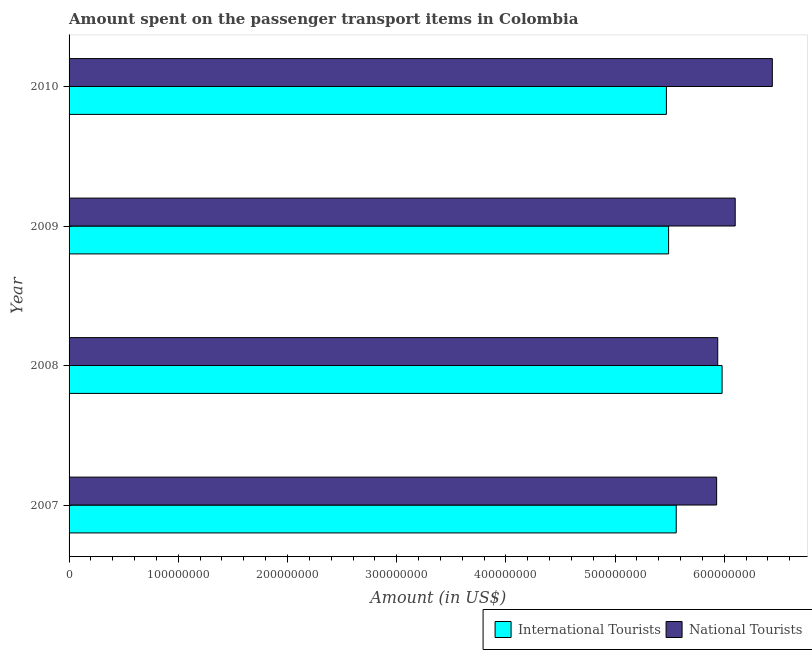Are the number of bars per tick equal to the number of legend labels?
Offer a terse response. Yes. How many bars are there on the 2nd tick from the top?
Your response must be concise. 2. How many bars are there on the 1st tick from the bottom?
Make the answer very short. 2. What is the label of the 1st group of bars from the top?
Keep it short and to the point. 2010. In how many cases, is the number of bars for a given year not equal to the number of legend labels?
Your answer should be very brief. 0. What is the amount spent on transport items of national tourists in 2008?
Offer a very short reply. 5.94e+08. Across all years, what is the maximum amount spent on transport items of national tourists?
Offer a terse response. 6.44e+08. Across all years, what is the minimum amount spent on transport items of national tourists?
Your answer should be compact. 5.93e+08. In which year was the amount spent on transport items of international tourists maximum?
Your answer should be very brief. 2008. In which year was the amount spent on transport items of national tourists minimum?
Your response must be concise. 2007. What is the total amount spent on transport items of national tourists in the graph?
Provide a succinct answer. 2.44e+09. What is the difference between the amount spent on transport items of national tourists in 2009 and that in 2010?
Your answer should be very brief. -3.40e+07. What is the difference between the amount spent on transport items of international tourists in 2008 and the amount spent on transport items of national tourists in 2007?
Provide a succinct answer. 5.00e+06. What is the average amount spent on transport items of national tourists per year?
Keep it short and to the point. 6.10e+08. In the year 2010, what is the difference between the amount spent on transport items of international tourists and amount spent on transport items of national tourists?
Your response must be concise. -9.70e+07. In how many years, is the amount spent on transport items of national tourists greater than 380000000 US$?
Your answer should be compact. 4. What is the ratio of the amount spent on transport items of national tourists in 2007 to that in 2010?
Offer a terse response. 0.92. Is the amount spent on transport items of international tourists in 2007 less than that in 2008?
Provide a succinct answer. Yes. Is the difference between the amount spent on transport items of national tourists in 2007 and 2008 greater than the difference between the amount spent on transport items of international tourists in 2007 and 2008?
Ensure brevity in your answer.  Yes. What is the difference between the highest and the second highest amount spent on transport items of international tourists?
Your answer should be compact. 4.20e+07. What is the difference between the highest and the lowest amount spent on transport items of national tourists?
Give a very brief answer. 5.10e+07. Is the sum of the amount spent on transport items of national tourists in 2008 and 2010 greater than the maximum amount spent on transport items of international tourists across all years?
Make the answer very short. Yes. What does the 1st bar from the top in 2007 represents?
Provide a succinct answer. National Tourists. What does the 1st bar from the bottom in 2009 represents?
Your answer should be compact. International Tourists. How many bars are there?
Ensure brevity in your answer.  8. What is the difference between two consecutive major ticks on the X-axis?
Keep it short and to the point. 1.00e+08. Are the values on the major ticks of X-axis written in scientific E-notation?
Provide a short and direct response. No. Where does the legend appear in the graph?
Keep it short and to the point. Bottom right. What is the title of the graph?
Make the answer very short. Amount spent on the passenger transport items in Colombia. Does "Male labourers" appear as one of the legend labels in the graph?
Ensure brevity in your answer.  No. What is the label or title of the Y-axis?
Offer a very short reply. Year. What is the Amount (in US$) of International Tourists in 2007?
Your answer should be very brief. 5.56e+08. What is the Amount (in US$) in National Tourists in 2007?
Give a very brief answer. 5.93e+08. What is the Amount (in US$) in International Tourists in 2008?
Your answer should be very brief. 5.98e+08. What is the Amount (in US$) of National Tourists in 2008?
Make the answer very short. 5.94e+08. What is the Amount (in US$) of International Tourists in 2009?
Make the answer very short. 5.49e+08. What is the Amount (in US$) in National Tourists in 2009?
Keep it short and to the point. 6.10e+08. What is the Amount (in US$) in International Tourists in 2010?
Offer a very short reply. 5.47e+08. What is the Amount (in US$) of National Tourists in 2010?
Offer a terse response. 6.44e+08. Across all years, what is the maximum Amount (in US$) of International Tourists?
Provide a short and direct response. 5.98e+08. Across all years, what is the maximum Amount (in US$) of National Tourists?
Provide a succinct answer. 6.44e+08. Across all years, what is the minimum Amount (in US$) of International Tourists?
Your answer should be very brief. 5.47e+08. Across all years, what is the minimum Amount (in US$) of National Tourists?
Keep it short and to the point. 5.93e+08. What is the total Amount (in US$) in International Tourists in the graph?
Provide a short and direct response. 2.25e+09. What is the total Amount (in US$) in National Tourists in the graph?
Give a very brief answer. 2.44e+09. What is the difference between the Amount (in US$) of International Tourists in 2007 and that in 2008?
Keep it short and to the point. -4.20e+07. What is the difference between the Amount (in US$) of National Tourists in 2007 and that in 2008?
Your answer should be compact. -1.00e+06. What is the difference between the Amount (in US$) in National Tourists in 2007 and that in 2009?
Give a very brief answer. -1.70e+07. What is the difference between the Amount (in US$) of International Tourists in 2007 and that in 2010?
Provide a succinct answer. 9.00e+06. What is the difference between the Amount (in US$) in National Tourists in 2007 and that in 2010?
Ensure brevity in your answer.  -5.10e+07. What is the difference between the Amount (in US$) of International Tourists in 2008 and that in 2009?
Provide a short and direct response. 4.90e+07. What is the difference between the Amount (in US$) in National Tourists in 2008 and that in 2009?
Provide a short and direct response. -1.60e+07. What is the difference between the Amount (in US$) in International Tourists in 2008 and that in 2010?
Your answer should be compact. 5.10e+07. What is the difference between the Amount (in US$) in National Tourists in 2008 and that in 2010?
Your answer should be compact. -5.00e+07. What is the difference between the Amount (in US$) in International Tourists in 2009 and that in 2010?
Provide a succinct answer. 2.00e+06. What is the difference between the Amount (in US$) in National Tourists in 2009 and that in 2010?
Ensure brevity in your answer.  -3.40e+07. What is the difference between the Amount (in US$) of International Tourists in 2007 and the Amount (in US$) of National Tourists in 2008?
Your answer should be compact. -3.80e+07. What is the difference between the Amount (in US$) in International Tourists in 2007 and the Amount (in US$) in National Tourists in 2009?
Your answer should be very brief. -5.40e+07. What is the difference between the Amount (in US$) of International Tourists in 2007 and the Amount (in US$) of National Tourists in 2010?
Offer a terse response. -8.80e+07. What is the difference between the Amount (in US$) of International Tourists in 2008 and the Amount (in US$) of National Tourists in 2009?
Provide a succinct answer. -1.20e+07. What is the difference between the Amount (in US$) of International Tourists in 2008 and the Amount (in US$) of National Tourists in 2010?
Your answer should be very brief. -4.60e+07. What is the difference between the Amount (in US$) of International Tourists in 2009 and the Amount (in US$) of National Tourists in 2010?
Offer a very short reply. -9.50e+07. What is the average Amount (in US$) of International Tourists per year?
Offer a terse response. 5.62e+08. What is the average Amount (in US$) in National Tourists per year?
Make the answer very short. 6.10e+08. In the year 2007, what is the difference between the Amount (in US$) in International Tourists and Amount (in US$) in National Tourists?
Keep it short and to the point. -3.70e+07. In the year 2009, what is the difference between the Amount (in US$) of International Tourists and Amount (in US$) of National Tourists?
Your response must be concise. -6.10e+07. In the year 2010, what is the difference between the Amount (in US$) in International Tourists and Amount (in US$) in National Tourists?
Offer a very short reply. -9.70e+07. What is the ratio of the Amount (in US$) in International Tourists in 2007 to that in 2008?
Your response must be concise. 0.93. What is the ratio of the Amount (in US$) of International Tourists in 2007 to that in 2009?
Make the answer very short. 1.01. What is the ratio of the Amount (in US$) in National Tourists in 2007 to that in 2009?
Your response must be concise. 0.97. What is the ratio of the Amount (in US$) in International Tourists in 2007 to that in 2010?
Offer a very short reply. 1.02. What is the ratio of the Amount (in US$) in National Tourists in 2007 to that in 2010?
Offer a terse response. 0.92. What is the ratio of the Amount (in US$) of International Tourists in 2008 to that in 2009?
Your answer should be very brief. 1.09. What is the ratio of the Amount (in US$) of National Tourists in 2008 to that in 2009?
Keep it short and to the point. 0.97. What is the ratio of the Amount (in US$) in International Tourists in 2008 to that in 2010?
Keep it short and to the point. 1.09. What is the ratio of the Amount (in US$) in National Tourists in 2008 to that in 2010?
Offer a very short reply. 0.92. What is the ratio of the Amount (in US$) of International Tourists in 2009 to that in 2010?
Offer a very short reply. 1. What is the ratio of the Amount (in US$) in National Tourists in 2009 to that in 2010?
Provide a short and direct response. 0.95. What is the difference between the highest and the second highest Amount (in US$) in International Tourists?
Ensure brevity in your answer.  4.20e+07. What is the difference between the highest and the second highest Amount (in US$) of National Tourists?
Your answer should be very brief. 3.40e+07. What is the difference between the highest and the lowest Amount (in US$) of International Tourists?
Provide a succinct answer. 5.10e+07. What is the difference between the highest and the lowest Amount (in US$) in National Tourists?
Give a very brief answer. 5.10e+07. 